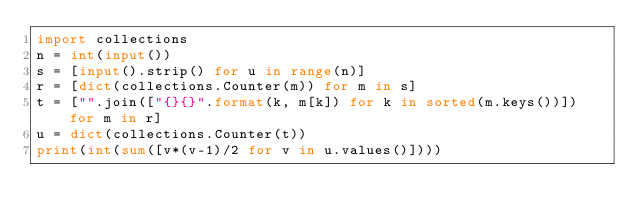Convert code to text. <code><loc_0><loc_0><loc_500><loc_500><_Python_>import collections
n = int(input())
s = [input().strip() for u in range(n)]
r = [dict(collections.Counter(m)) for m in s]
t = ["".join(["{}{}".format(k, m[k]) for k in sorted(m.keys())]) for m in r]
u = dict(collections.Counter(t))
print(int(sum([v*(v-1)/2 for v in u.values()])))</code> 